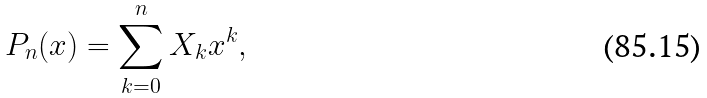Convert formula to latex. <formula><loc_0><loc_0><loc_500><loc_500>P _ { n } ( x ) = \sum _ { k = 0 } ^ { n } { X _ { k } x ^ { k } } ,</formula> 